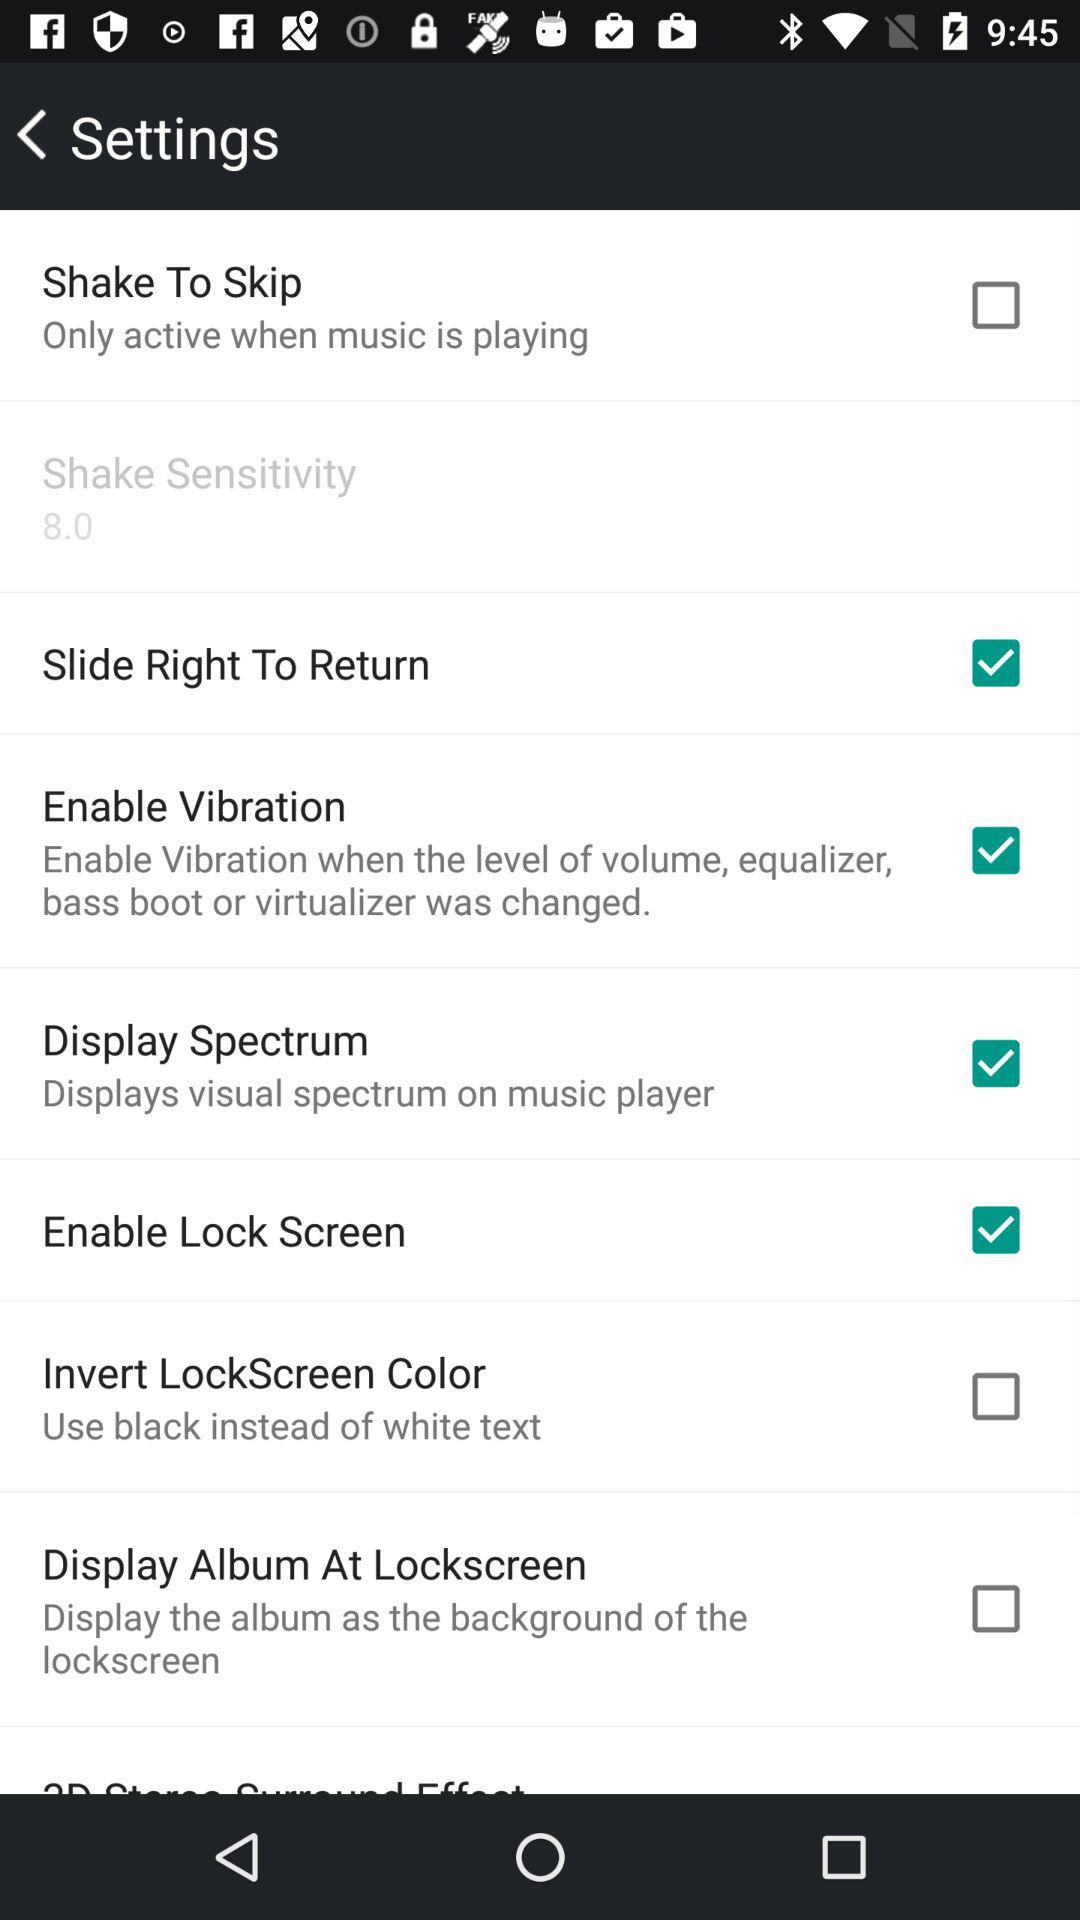What is the status of "Enable Vibration"? The status of "Enable Vibration" is "on". 